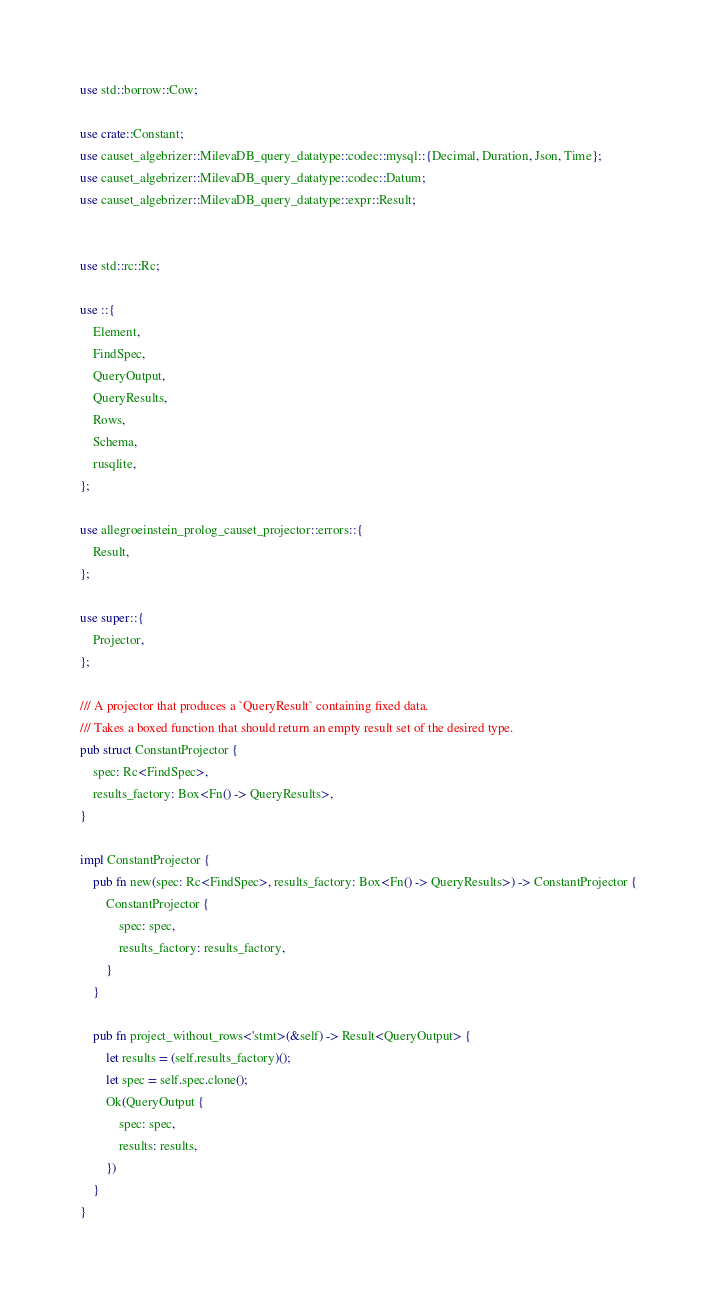<code> <loc_0><loc_0><loc_500><loc_500><_Rust_>use std::borrow::Cow;

use crate::Constant;
use causet_algebrizer::MilevaDB_query_datatype::codec::mysql::{Decimal, Duration, Json, Time};
use causet_algebrizer::MilevaDB_query_datatype::codec::Datum;
use causet_algebrizer::MilevaDB_query_datatype::expr::Result;


use std::rc::Rc;

use ::{
    Element,
    FindSpec,
    QueryOutput,
    QueryResults,
    Rows,
    Schema,
    rusqlite,
};

use allegroeinstein_prolog_causet_projector::errors::{
    Result,
};

use super::{
    Projector,
};

/// A projector that produces a `QueryResult` containing fixed data.
/// Takes a boxed function that should return an empty result set of the desired type.
pub struct ConstantProjector {
    spec: Rc<FindSpec>,
    results_factory: Box<Fn() -> QueryResults>,
}

impl ConstantProjector {
    pub fn new(spec: Rc<FindSpec>, results_factory: Box<Fn() -> QueryResults>) -> ConstantProjector {
        ConstantProjector {
            spec: spec,
            results_factory: results_factory,
        }
    }

    pub fn project_without_rows<'stmt>(&self) -> Result<QueryOutput> {
        let results = (self.results_factory)();
        let spec = self.spec.clone();
        Ok(QueryOutput {
            spec: spec,
            results: results,
        })
    }
}
</code> 